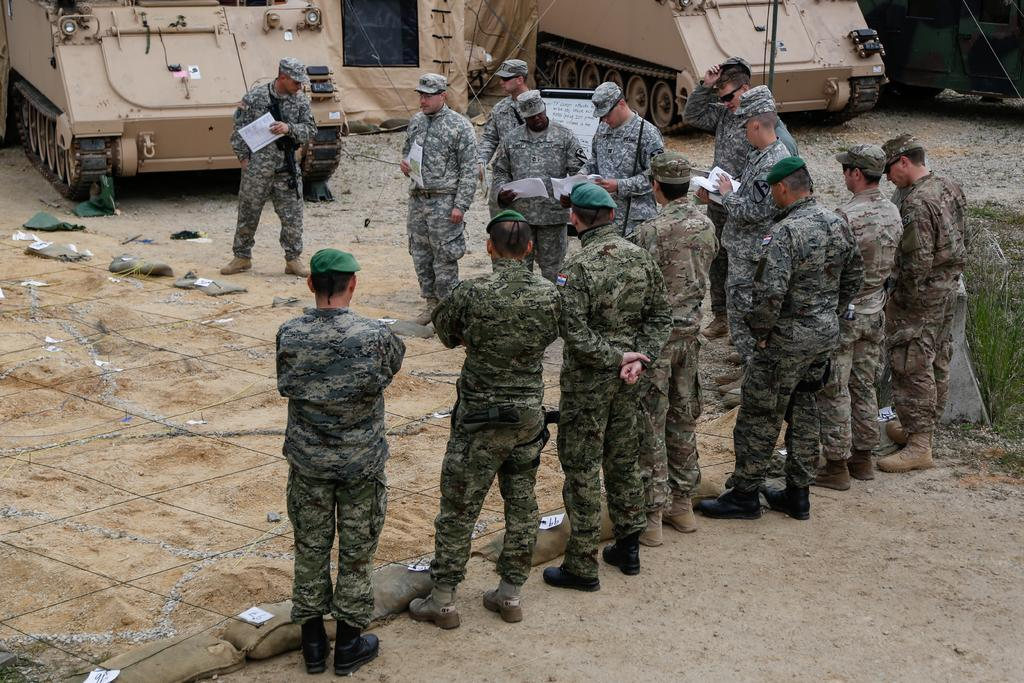What type of clothing are the men in the image wearing? The men in the image are wearing army uniforms. What can be seen beneath the men's feet in the image? There is ground visible in the image. What type of vehicles are present in the image? There are tanks in the image. What type of vegetation can be seen in the image? There are plants in the image. What type of twig is being used as a weapon by the men in the image? There is no twig being used as a weapon in the image; the men are wearing army uniforms and are likely using more conventional weapons. 